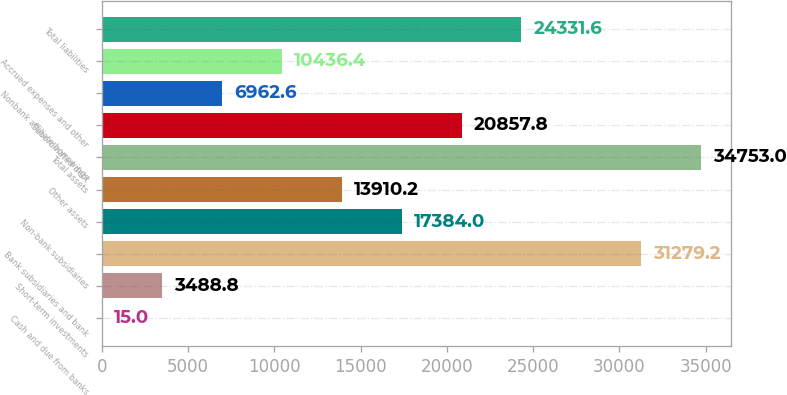Convert chart. <chart><loc_0><loc_0><loc_500><loc_500><bar_chart><fcel>Cash and due from banks<fcel>Short-term investments<fcel>Bank subsidiaries and bank<fcel>Non-bank subsidiaries<fcel>Other assets<fcel>Total assets<fcel>Subordinated debt<fcel>Nonbank affiliate borrowings<fcel>Accrued expenses and other<fcel>Total liabilities<nl><fcel>15<fcel>3488.8<fcel>31279.2<fcel>17384<fcel>13910.2<fcel>34753<fcel>20857.8<fcel>6962.6<fcel>10436.4<fcel>24331.6<nl></chart> 